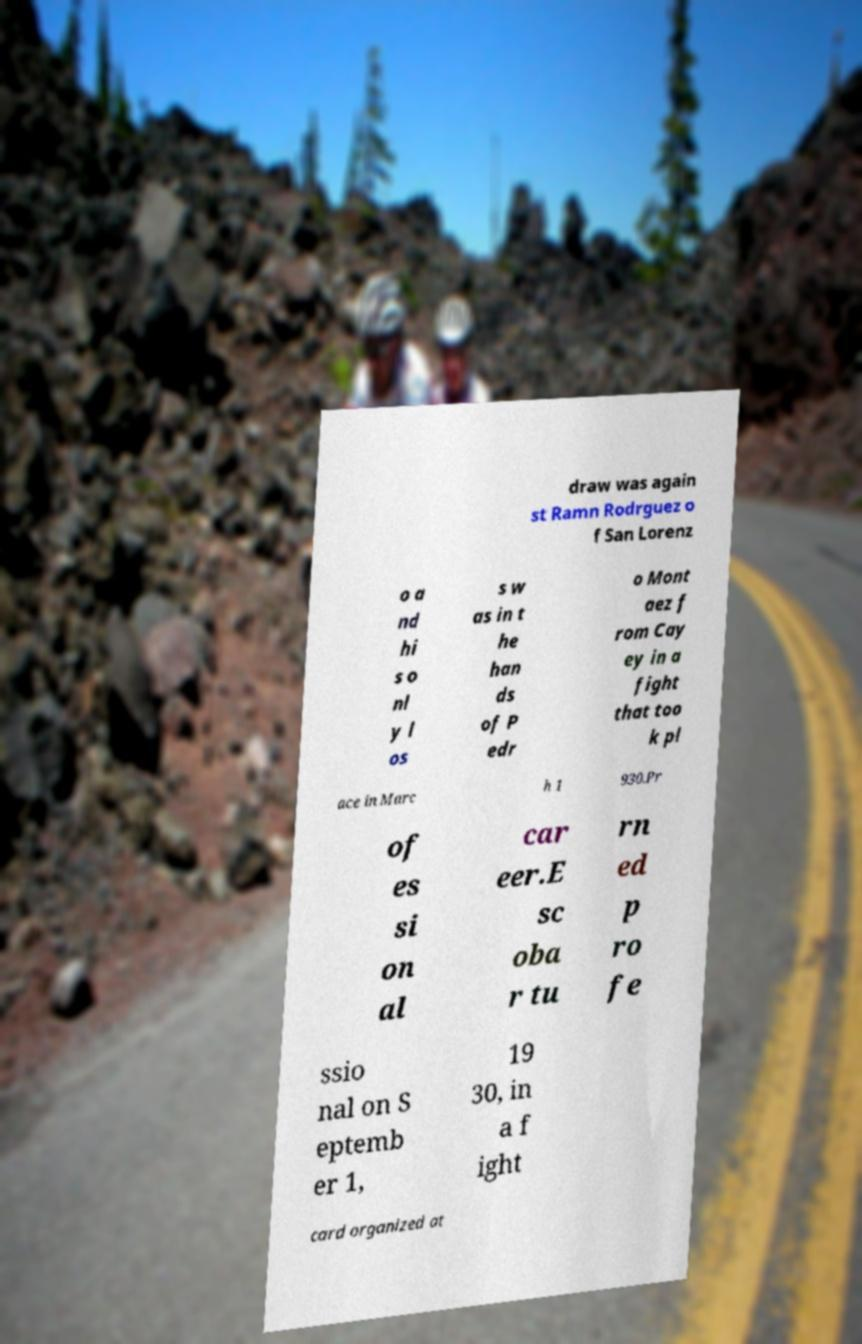I need the written content from this picture converted into text. Can you do that? draw was again st Ramn Rodrguez o f San Lorenz o a nd hi s o nl y l os s w as in t he han ds of P edr o Mont aez f rom Cay ey in a fight that too k pl ace in Marc h 1 930.Pr of es si on al car eer.E sc oba r tu rn ed p ro fe ssio nal on S eptemb er 1, 19 30, in a f ight card organized at 